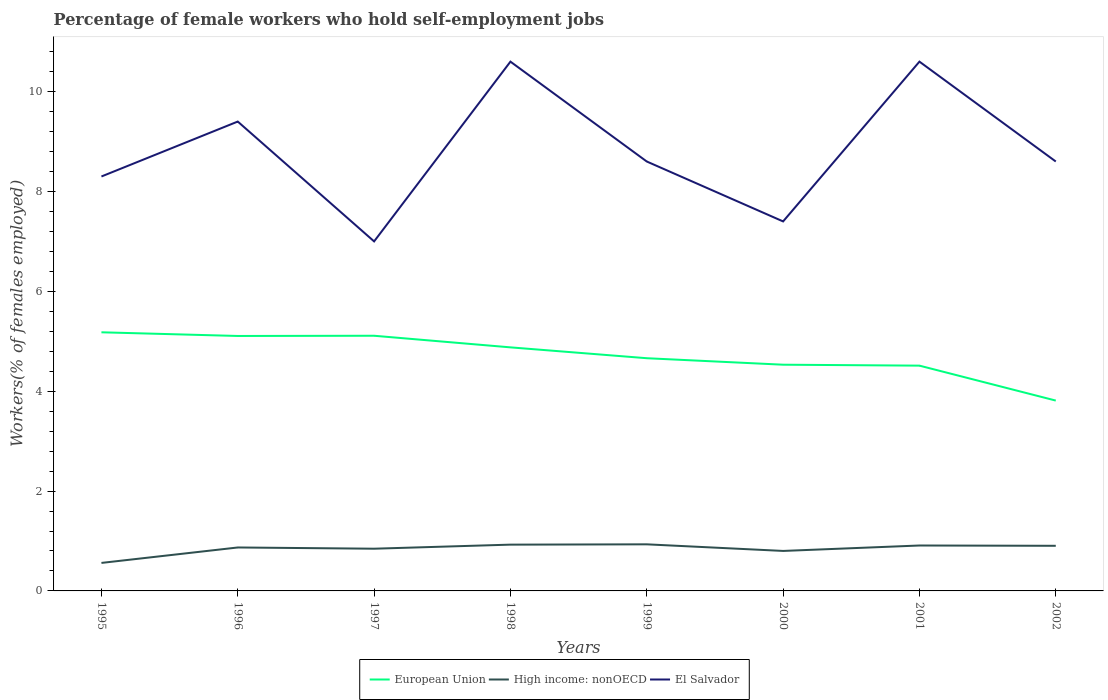How many different coloured lines are there?
Make the answer very short. 3. Does the line corresponding to El Salvador intersect with the line corresponding to European Union?
Your response must be concise. No. Is the number of lines equal to the number of legend labels?
Offer a terse response. Yes. Across all years, what is the maximum percentage of self-employed female workers in High income: nonOECD?
Offer a very short reply. 0.56. What is the total percentage of self-employed female workers in European Union in the graph?
Offer a terse response. 0.58. What is the difference between the highest and the second highest percentage of self-employed female workers in High income: nonOECD?
Give a very brief answer. 0.37. Does the graph contain grids?
Provide a short and direct response. No. Where does the legend appear in the graph?
Provide a succinct answer. Bottom center. How many legend labels are there?
Your response must be concise. 3. What is the title of the graph?
Your response must be concise. Percentage of female workers who hold self-employment jobs. Does "OECD members" appear as one of the legend labels in the graph?
Make the answer very short. No. What is the label or title of the Y-axis?
Keep it short and to the point. Workers(% of females employed). What is the Workers(% of females employed) in European Union in 1995?
Your response must be concise. 5.18. What is the Workers(% of females employed) of High income: nonOECD in 1995?
Your answer should be compact. 0.56. What is the Workers(% of females employed) in El Salvador in 1995?
Offer a terse response. 8.3. What is the Workers(% of females employed) in European Union in 1996?
Provide a short and direct response. 5.11. What is the Workers(% of females employed) of High income: nonOECD in 1996?
Provide a short and direct response. 0.87. What is the Workers(% of females employed) of El Salvador in 1996?
Your answer should be very brief. 9.4. What is the Workers(% of females employed) of European Union in 1997?
Offer a terse response. 5.11. What is the Workers(% of females employed) in High income: nonOECD in 1997?
Provide a short and direct response. 0.85. What is the Workers(% of females employed) in European Union in 1998?
Give a very brief answer. 4.88. What is the Workers(% of females employed) in High income: nonOECD in 1998?
Your response must be concise. 0.93. What is the Workers(% of females employed) of El Salvador in 1998?
Offer a very short reply. 10.6. What is the Workers(% of females employed) in European Union in 1999?
Your response must be concise. 4.66. What is the Workers(% of females employed) in High income: nonOECD in 1999?
Provide a short and direct response. 0.93. What is the Workers(% of females employed) of El Salvador in 1999?
Your response must be concise. 8.6. What is the Workers(% of females employed) in European Union in 2000?
Your answer should be very brief. 4.53. What is the Workers(% of females employed) in High income: nonOECD in 2000?
Keep it short and to the point. 0.8. What is the Workers(% of females employed) in El Salvador in 2000?
Provide a succinct answer. 7.4. What is the Workers(% of females employed) in European Union in 2001?
Provide a short and direct response. 4.51. What is the Workers(% of females employed) of High income: nonOECD in 2001?
Offer a very short reply. 0.91. What is the Workers(% of females employed) of El Salvador in 2001?
Ensure brevity in your answer.  10.6. What is the Workers(% of females employed) in European Union in 2002?
Offer a terse response. 3.81. What is the Workers(% of females employed) in High income: nonOECD in 2002?
Your response must be concise. 0.9. What is the Workers(% of females employed) of El Salvador in 2002?
Provide a succinct answer. 8.6. Across all years, what is the maximum Workers(% of females employed) in European Union?
Provide a short and direct response. 5.18. Across all years, what is the maximum Workers(% of females employed) in High income: nonOECD?
Keep it short and to the point. 0.93. Across all years, what is the maximum Workers(% of females employed) in El Salvador?
Make the answer very short. 10.6. Across all years, what is the minimum Workers(% of females employed) of European Union?
Ensure brevity in your answer.  3.81. Across all years, what is the minimum Workers(% of females employed) of High income: nonOECD?
Offer a very short reply. 0.56. Across all years, what is the minimum Workers(% of females employed) in El Salvador?
Your response must be concise. 7. What is the total Workers(% of females employed) of European Union in the graph?
Make the answer very short. 37.79. What is the total Workers(% of females employed) in High income: nonOECD in the graph?
Your response must be concise. 6.75. What is the total Workers(% of females employed) in El Salvador in the graph?
Make the answer very short. 70.5. What is the difference between the Workers(% of females employed) of European Union in 1995 and that in 1996?
Make the answer very short. 0.07. What is the difference between the Workers(% of females employed) in High income: nonOECD in 1995 and that in 1996?
Your answer should be very brief. -0.31. What is the difference between the Workers(% of females employed) in El Salvador in 1995 and that in 1996?
Offer a very short reply. -1.1. What is the difference between the Workers(% of females employed) of European Union in 1995 and that in 1997?
Give a very brief answer. 0.07. What is the difference between the Workers(% of females employed) of High income: nonOECD in 1995 and that in 1997?
Give a very brief answer. -0.28. What is the difference between the Workers(% of females employed) in El Salvador in 1995 and that in 1997?
Provide a succinct answer. 1.3. What is the difference between the Workers(% of females employed) of European Union in 1995 and that in 1998?
Give a very brief answer. 0.3. What is the difference between the Workers(% of females employed) in High income: nonOECD in 1995 and that in 1998?
Your answer should be very brief. -0.37. What is the difference between the Workers(% of females employed) of European Union in 1995 and that in 1999?
Ensure brevity in your answer.  0.52. What is the difference between the Workers(% of females employed) of High income: nonOECD in 1995 and that in 1999?
Provide a succinct answer. -0.37. What is the difference between the Workers(% of females employed) of El Salvador in 1995 and that in 1999?
Your answer should be compact. -0.3. What is the difference between the Workers(% of females employed) of European Union in 1995 and that in 2000?
Offer a very short reply. 0.65. What is the difference between the Workers(% of females employed) in High income: nonOECD in 1995 and that in 2000?
Offer a very short reply. -0.24. What is the difference between the Workers(% of females employed) in El Salvador in 1995 and that in 2000?
Offer a terse response. 0.9. What is the difference between the Workers(% of females employed) of European Union in 1995 and that in 2001?
Make the answer very short. 0.67. What is the difference between the Workers(% of females employed) in High income: nonOECD in 1995 and that in 2001?
Give a very brief answer. -0.35. What is the difference between the Workers(% of females employed) in El Salvador in 1995 and that in 2001?
Give a very brief answer. -2.3. What is the difference between the Workers(% of females employed) of European Union in 1995 and that in 2002?
Provide a short and direct response. 1.37. What is the difference between the Workers(% of females employed) in High income: nonOECD in 1995 and that in 2002?
Offer a very short reply. -0.34. What is the difference between the Workers(% of females employed) of El Salvador in 1995 and that in 2002?
Provide a succinct answer. -0.3. What is the difference between the Workers(% of females employed) in European Union in 1996 and that in 1997?
Make the answer very short. -0. What is the difference between the Workers(% of females employed) of High income: nonOECD in 1996 and that in 1997?
Offer a very short reply. 0.02. What is the difference between the Workers(% of females employed) in European Union in 1996 and that in 1998?
Make the answer very short. 0.23. What is the difference between the Workers(% of females employed) of High income: nonOECD in 1996 and that in 1998?
Keep it short and to the point. -0.06. What is the difference between the Workers(% of females employed) of El Salvador in 1996 and that in 1998?
Your answer should be very brief. -1.2. What is the difference between the Workers(% of females employed) of European Union in 1996 and that in 1999?
Your answer should be very brief. 0.45. What is the difference between the Workers(% of females employed) of High income: nonOECD in 1996 and that in 1999?
Offer a terse response. -0.06. What is the difference between the Workers(% of females employed) in El Salvador in 1996 and that in 1999?
Provide a short and direct response. 0.8. What is the difference between the Workers(% of females employed) of European Union in 1996 and that in 2000?
Make the answer very short. 0.58. What is the difference between the Workers(% of females employed) in High income: nonOECD in 1996 and that in 2000?
Offer a very short reply. 0.07. What is the difference between the Workers(% of females employed) in El Salvador in 1996 and that in 2000?
Keep it short and to the point. 2. What is the difference between the Workers(% of females employed) in European Union in 1996 and that in 2001?
Provide a succinct answer. 0.59. What is the difference between the Workers(% of females employed) in High income: nonOECD in 1996 and that in 2001?
Provide a short and direct response. -0.04. What is the difference between the Workers(% of females employed) in El Salvador in 1996 and that in 2001?
Make the answer very short. -1.2. What is the difference between the Workers(% of females employed) of European Union in 1996 and that in 2002?
Provide a short and direct response. 1.29. What is the difference between the Workers(% of females employed) in High income: nonOECD in 1996 and that in 2002?
Provide a short and direct response. -0.03. What is the difference between the Workers(% of females employed) in El Salvador in 1996 and that in 2002?
Ensure brevity in your answer.  0.8. What is the difference between the Workers(% of females employed) of European Union in 1997 and that in 1998?
Your answer should be very brief. 0.23. What is the difference between the Workers(% of females employed) in High income: nonOECD in 1997 and that in 1998?
Your answer should be very brief. -0.08. What is the difference between the Workers(% of females employed) of El Salvador in 1997 and that in 1998?
Your response must be concise. -3.6. What is the difference between the Workers(% of females employed) of European Union in 1997 and that in 1999?
Your answer should be very brief. 0.45. What is the difference between the Workers(% of females employed) in High income: nonOECD in 1997 and that in 1999?
Your answer should be very brief. -0.09. What is the difference between the Workers(% of females employed) in European Union in 1997 and that in 2000?
Provide a succinct answer. 0.58. What is the difference between the Workers(% of females employed) in High income: nonOECD in 1997 and that in 2000?
Provide a succinct answer. 0.04. What is the difference between the Workers(% of females employed) in European Union in 1997 and that in 2001?
Ensure brevity in your answer.  0.6. What is the difference between the Workers(% of females employed) of High income: nonOECD in 1997 and that in 2001?
Make the answer very short. -0.06. What is the difference between the Workers(% of females employed) in El Salvador in 1997 and that in 2001?
Provide a succinct answer. -3.6. What is the difference between the Workers(% of females employed) of European Union in 1997 and that in 2002?
Offer a very short reply. 1.3. What is the difference between the Workers(% of females employed) of High income: nonOECD in 1997 and that in 2002?
Your response must be concise. -0.06. What is the difference between the Workers(% of females employed) in European Union in 1998 and that in 1999?
Your response must be concise. 0.22. What is the difference between the Workers(% of females employed) of High income: nonOECD in 1998 and that in 1999?
Offer a very short reply. -0.01. What is the difference between the Workers(% of females employed) of European Union in 1998 and that in 2000?
Offer a terse response. 0.35. What is the difference between the Workers(% of females employed) of High income: nonOECD in 1998 and that in 2000?
Provide a short and direct response. 0.13. What is the difference between the Workers(% of females employed) in El Salvador in 1998 and that in 2000?
Your response must be concise. 3.2. What is the difference between the Workers(% of females employed) in European Union in 1998 and that in 2001?
Keep it short and to the point. 0.37. What is the difference between the Workers(% of females employed) of High income: nonOECD in 1998 and that in 2001?
Your answer should be compact. 0.02. What is the difference between the Workers(% of females employed) in El Salvador in 1998 and that in 2001?
Keep it short and to the point. 0. What is the difference between the Workers(% of females employed) of European Union in 1998 and that in 2002?
Keep it short and to the point. 1.07. What is the difference between the Workers(% of females employed) of High income: nonOECD in 1998 and that in 2002?
Offer a very short reply. 0.02. What is the difference between the Workers(% of females employed) in El Salvador in 1998 and that in 2002?
Ensure brevity in your answer.  2. What is the difference between the Workers(% of females employed) of European Union in 1999 and that in 2000?
Your answer should be compact. 0.13. What is the difference between the Workers(% of females employed) in High income: nonOECD in 1999 and that in 2000?
Offer a terse response. 0.13. What is the difference between the Workers(% of females employed) of European Union in 1999 and that in 2001?
Offer a terse response. 0.15. What is the difference between the Workers(% of females employed) of High income: nonOECD in 1999 and that in 2001?
Give a very brief answer. 0.02. What is the difference between the Workers(% of females employed) in El Salvador in 1999 and that in 2001?
Your answer should be very brief. -2. What is the difference between the Workers(% of females employed) in European Union in 1999 and that in 2002?
Ensure brevity in your answer.  0.85. What is the difference between the Workers(% of females employed) of High income: nonOECD in 1999 and that in 2002?
Offer a terse response. 0.03. What is the difference between the Workers(% of females employed) in European Union in 2000 and that in 2001?
Ensure brevity in your answer.  0.02. What is the difference between the Workers(% of females employed) in High income: nonOECD in 2000 and that in 2001?
Ensure brevity in your answer.  -0.11. What is the difference between the Workers(% of females employed) in El Salvador in 2000 and that in 2001?
Ensure brevity in your answer.  -3.2. What is the difference between the Workers(% of females employed) in European Union in 2000 and that in 2002?
Provide a short and direct response. 0.72. What is the difference between the Workers(% of females employed) of High income: nonOECD in 2000 and that in 2002?
Give a very brief answer. -0.1. What is the difference between the Workers(% of females employed) of El Salvador in 2000 and that in 2002?
Your answer should be very brief. -1.2. What is the difference between the Workers(% of females employed) of European Union in 2001 and that in 2002?
Offer a very short reply. 0.7. What is the difference between the Workers(% of females employed) in High income: nonOECD in 2001 and that in 2002?
Your answer should be compact. 0.01. What is the difference between the Workers(% of females employed) in El Salvador in 2001 and that in 2002?
Make the answer very short. 2. What is the difference between the Workers(% of females employed) of European Union in 1995 and the Workers(% of females employed) of High income: nonOECD in 1996?
Give a very brief answer. 4.31. What is the difference between the Workers(% of females employed) of European Union in 1995 and the Workers(% of females employed) of El Salvador in 1996?
Your answer should be very brief. -4.22. What is the difference between the Workers(% of females employed) in High income: nonOECD in 1995 and the Workers(% of females employed) in El Salvador in 1996?
Make the answer very short. -8.84. What is the difference between the Workers(% of females employed) in European Union in 1995 and the Workers(% of females employed) in High income: nonOECD in 1997?
Offer a very short reply. 4.33. What is the difference between the Workers(% of females employed) in European Union in 1995 and the Workers(% of females employed) in El Salvador in 1997?
Your answer should be compact. -1.82. What is the difference between the Workers(% of females employed) in High income: nonOECD in 1995 and the Workers(% of females employed) in El Salvador in 1997?
Provide a succinct answer. -6.44. What is the difference between the Workers(% of females employed) of European Union in 1995 and the Workers(% of females employed) of High income: nonOECD in 1998?
Give a very brief answer. 4.25. What is the difference between the Workers(% of females employed) of European Union in 1995 and the Workers(% of females employed) of El Salvador in 1998?
Offer a very short reply. -5.42. What is the difference between the Workers(% of females employed) in High income: nonOECD in 1995 and the Workers(% of females employed) in El Salvador in 1998?
Provide a short and direct response. -10.04. What is the difference between the Workers(% of females employed) in European Union in 1995 and the Workers(% of females employed) in High income: nonOECD in 1999?
Offer a terse response. 4.25. What is the difference between the Workers(% of females employed) of European Union in 1995 and the Workers(% of females employed) of El Salvador in 1999?
Give a very brief answer. -3.42. What is the difference between the Workers(% of females employed) in High income: nonOECD in 1995 and the Workers(% of females employed) in El Salvador in 1999?
Provide a short and direct response. -8.04. What is the difference between the Workers(% of females employed) in European Union in 1995 and the Workers(% of females employed) in High income: nonOECD in 2000?
Offer a very short reply. 4.38. What is the difference between the Workers(% of females employed) of European Union in 1995 and the Workers(% of females employed) of El Salvador in 2000?
Make the answer very short. -2.22. What is the difference between the Workers(% of females employed) of High income: nonOECD in 1995 and the Workers(% of females employed) of El Salvador in 2000?
Provide a succinct answer. -6.84. What is the difference between the Workers(% of females employed) of European Union in 1995 and the Workers(% of females employed) of High income: nonOECD in 2001?
Ensure brevity in your answer.  4.27. What is the difference between the Workers(% of females employed) of European Union in 1995 and the Workers(% of females employed) of El Salvador in 2001?
Keep it short and to the point. -5.42. What is the difference between the Workers(% of females employed) of High income: nonOECD in 1995 and the Workers(% of females employed) of El Salvador in 2001?
Ensure brevity in your answer.  -10.04. What is the difference between the Workers(% of females employed) in European Union in 1995 and the Workers(% of females employed) in High income: nonOECD in 2002?
Keep it short and to the point. 4.28. What is the difference between the Workers(% of females employed) of European Union in 1995 and the Workers(% of females employed) of El Salvador in 2002?
Provide a succinct answer. -3.42. What is the difference between the Workers(% of females employed) of High income: nonOECD in 1995 and the Workers(% of females employed) of El Salvador in 2002?
Provide a succinct answer. -8.04. What is the difference between the Workers(% of females employed) of European Union in 1996 and the Workers(% of females employed) of High income: nonOECD in 1997?
Provide a succinct answer. 4.26. What is the difference between the Workers(% of females employed) of European Union in 1996 and the Workers(% of females employed) of El Salvador in 1997?
Your response must be concise. -1.89. What is the difference between the Workers(% of females employed) of High income: nonOECD in 1996 and the Workers(% of females employed) of El Salvador in 1997?
Provide a succinct answer. -6.13. What is the difference between the Workers(% of females employed) of European Union in 1996 and the Workers(% of females employed) of High income: nonOECD in 1998?
Make the answer very short. 4.18. What is the difference between the Workers(% of females employed) of European Union in 1996 and the Workers(% of females employed) of El Salvador in 1998?
Offer a terse response. -5.49. What is the difference between the Workers(% of females employed) of High income: nonOECD in 1996 and the Workers(% of females employed) of El Salvador in 1998?
Give a very brief answer. -9.73. What is the difference between the Workers(% of females employed) in European Union in 1996 and the Workers(% of females employed) in High income: nonOECD in 1999?
Make the answer very short. 4.17. What is the difference between the Workers(% of females employed) in European Union in 1996 and the Workers(% of females employed) in El Salvador in 1999?
Keep it short and to the point. -3.49. What is the difference between the Workers(% of females employed) in High income: nonOECD in 1996 and the Workers(% of females employed) in El Salvador in 1999?
Offer a terse response. -7.73. What is the difference between the Workers(% of females employed) in European Union in 1996 and the Workers(% of females employed) in High income: nonOECD in 2000?
Offer a terse response. 4.3. What is the difference between the Workers(% of females employed) of European Union in 1996 and the Workers(% of females employed) of El Salvador in 2000?
Your response must be concise. -2.29. What is the difference between the Workers(% of females employed) of High income: nonOECD in 1996 and the Workers(% of females employed) of El Salvador in 2000?
Provide a succinct answer. -6.53. What is the difference between the Workers(% of females employed) of European Union in 1996 and the Workers(% of females employed) of High income: nonOECD in 2001?
Offer a very short reply. 4.2. What is the difference between the Workers(% of females employed) in European Union in 1996 and the Workers(% of females employed) in El Salvador in 2001?
Keep it short and to the point. -5.49. What is the difference between the Workers(% of females employed) of High income: nonOECD in 1996 and the Workers(% of females employed) of El Salvador in 2001?
Your response must be concise. -9.73. What is the difference between the Workers(% of females employed) of European Union in 1996 and the Workers(% of females employed) of High income: nonOECD in 2002?
Provide a short and direct response. 4.2. What is the difference between the Workers(% of females employed) of European Union in 1996 and the Workers(% of females employed) of El Salvador in 2002?
Make the answer very short. -3.49. What is the difference between the Workers(% of females employed) in High income: nonOECD in 1996 and the Workers(% of females employed) in El Salvador in 2002?
Offer a very short reply. -7.73. What is the difference between the Workers(% of females employed) of European Union in 1997 and the Workers(% of females employed) of High income: nonOECD in 1998?
Give a very brief answer. 4.18. What is the difference between the Workers(% of females employed) of European Union in 1997 and the Workers(% of females employed) of El Salvador in 1998?
Keep it short and to the point. -5.49. What is the difference between the Workers(% of females employed) in High income: nonOECD in 1997 and the Workers(% of females employed) in El Salvador in 1998?
Offer a terse response. -9.75. What is the difference between the Workers(% of females employed) of European Union in 1997 and the Workers(% of females employed) of High income: nonOECD in 1999?
Your response must be concise. 4.18. What is the difference between the Workers(% of females employed) in European Union in 1997 and the Workers(% of females employed) in El Salvador in 1999?
Provide a short and direct response. -3.49. What is the difference between the Workers(% of females employed) of High income: nonOECD in 1997 and the Workers(% of females employed) of El Salvador in 1999?
Keep it short and to the point. -7.75. What is the difference between the Workers(% of females employed) of European Union in 1997 and the Workers(% of females employed) of High income: nonOECD in 2000?
Provide a short and direct response. 4.31. What is the difference between the Workers(% of females employed) in European Union in 1997 and the Workers(% of females employed) in El Salvador in 2000?
Your answer should be compact. -2.29. What is the difference between the Workers(% of females employed) in High income: nonOECD in 1997 and the Workers(% of females employed) in El Salvador in 2000?
Offer a very short reply. -6.55. What is the difference between the Workers(% of females employed) of European Union in 1997 and the Workers(% of females employed) of High income: nonOECD in 2001?
Provide a short and direct response. 4.2. What is the difference between the Workers(% of females employed) of European Union in 1997 and the Workers(% of females employed) of El Salvador in 2001?
Ensure brevity in your answer.  -5.49. What is the difference between the Workers(% of females employed) in High income: nonOECD in 1997 and the Workers(% of females employed) in El Salvador in 2001?
Provide a succinct answer. -9.75. What is the difference between the Workers(% of females employed) of European Union in 1997 and the Workers(% of females employed) of High income: nonOECD in 2002?
Your answer should be very brief. 4.21. What is the difference between the Workers(% of females employed) in European Union in 1997 and the Workers(% of females employed) in El Salvador in 2002?
Keep it short and to the point. -3.49. What is the difference between the Workers(% of females employed) of High income: nonOECD in 1997 and the Workers(% of females employed) of El Salvador in 2002?
Give a very brief answer. -7.75. What is the difference between the Workers(% of females employed) in European Union in 1998 and the Workers(% of females employed) in High income: nonOECD in 1999?
Your response must be concise. 3.94. What is the difference between the Workers(% of females employed) of European Union in 1998 and the Workers(% of females employed) of El Salvador in 1999?
Make the answer very short. -3.72. What is the difference between the Workers(% of females employed) in High income: nonOECD in 1998 and the Workers(% of females employed) in El Salvador in 1999?
Ensure brevity in your answer.  -7.67. What is the difference between the Workers(% of females employed) in European Union in 1998 and the Workers(% of females employed) in High income: nonOECD in 2000?
Your response must be concise. 4.08. What is the difference between the Workers(% of females employed) in European Union in 1998 and the Workers(% of females employed) in El Salvador in 2000?
Your answer should be very brief. -2.52. What is the difference between the Workers(% of females employed) of High income: nonOECD in 1998 and the Workers(% of females employed) of El Salvador in 2000?
Offer a terse response. -6.47. What is the difference between the Workers(% of females employed) in European Union in 1998 and the Workers(% of females employed) in High income: nonOECD in 2001?
Give a very brief answer. 3.97. What is the difference between the Workers(% of females employed) of European Union in 1998 and the Workers(% of females employed) of El Salvador in 2001?
Keep it short and to the point. -5.72. What is the difference between the Workers(% of females employed) in High income: nonOECD in 1998 and the Workers(% of females employed) in El Salvador in 2001?
Your answer should be very brief. -9.67. What is the difference between the Workers(% of females employed) in European Union in 1998 and the Workers(% of females employed) in High income: nonOECD in 2002?
Your answer should be very brief. 3.97. What is the difference between the Workers(% of females employed) of European Union in 1998 and the Workers(% of females employed) of El Salvador in 2002?
Provide a short and direct response. -3.72. What is the difference between the Workers(% of females employed) of High income: nonOECD in 1998 and the Workers(% of females employed) of El Salvador in 2002?
Offer a terse response. -7.67. What is the difference between the Workers(% of females employed) in European Union in 1999 and the Workers(% of females employed) in High income: nonOECD in 2000?
Provide a short and direct response. 3.86. What is the difference between the Workers(% of females employed) of European Union in 1999 and the Workers(% of females employed) of El Salvador in 2000?
Your answer should be very brief. -2.74. What is the difference between the Workers(% of females employed) in High income: nonOECD in 1999 and the Workers(% of females employed) in El Salvador in 2000?
Ensure brevity in your answer.  -6.47. What is the difference between the Workers(% of females employed) of European Union in 1999 and the Workers(% of females employed) of High income: nonOECD in 2001?
Your response must be concise. 3.75. What is the difference between the Workers(% of females employed) in European Union in 1999 and the Workers(% of females employed) in El Salvador in 2001?
Ensure brevity in your answer.  -5.94. What is the difference between the Workers(% of females employed) of High income: nonOECD in 1999 and the Workers(% of females employed) of El Salvador in 2001?
Ensure brevity in your answer.  -9.67. What is the difference between the Workers(% of females employed) in European Union in 1999 and the Workers(% of females employed) in High income: nonOECD in 2002?
Offer a terse response. 3.76. What is the difference between the Workers(% of females employed) of European Union in 1999 and the Workers(% of females employed) of El Salvador in 2002?
Your answer should be compact. -3.94. What is the difference between the Workers(% of females employed) in High income: nonOECD in 1999 and the Workers(% of females employed) in El Salvador in 2002?
Offer a terse response. -7.67. What is the difference between the Workers(% of females employed) in European Union in 2000 and the Workers(% of females employed) in High income: nonOECD in 2001?
Your answer should be very brief. 3.62. What is the difference between the Workers(% of females employed) in European Union in 2000 and the Workers(% of females employed) in El Salvador in 2001?
Offer a very short reply. -6.07. What is the difference between the Workers(% of females employed) in High income: nonOECD in 2000 and the Workers(% of females employed) in El Salvador in 2001?
Give a very brief answer. -9.8. What is the difference between the Workers(% of females employed) in European Union in 2000 and the Workers(% of females employed) in High income: nonOECD in 2002?
Your answer should be compact. 3.63. What is the difference between the Workers(% of females employed) of European Union in 2000 and the Workers(% of females employed) of El Salvador in 2002?
Offer a terse response. -4.07. What is the difference between the Workers(% of females employed) of High income: nonOECD in 2000 and the Workers(% of females employed) of El Salvador in 2002?
Your answer should be compact. -7.8. What is the difference between the Workers(% of females employed) in European Union in 2001 and the Workers(% of females employed) in High income: nonOECD in 2002?
Offer a terse response. 3.61. What is the difference between the Workers(% of females employed) of European Union in 2001 and the Workers(% of females employed) of El Salvador in 2002?
Provide a short and direct response. -4.09. What is the difference between the Workers(% of females employed) of High income: nonOECD in 2001 and the Workers(% of females employed) of El Salvador in 2002?
Offer a very short reply. -7.69. What is the average Workers(% of females employed) in European Union per year?
Provide a short and direct response. 4.72. What is the average Workers(% of females employed) of High income: nonOECD per year?
Your answer should be very brief. 0.84. What is the average Workers(% of females employed) of El Salvador per year?
Offer a terse response. 8.81. In the year 1995, what is the difference between the Workers(% of females employed) in European Union and Workers(% of females employed) in High income: nonOECD?
Provide a short and direct response. 4.62. In the year 1995, what is the difference between the Workers(% of females employed) in European Union and Workers(% of females employed) in El Salvador?
Give a very brief answer. -3.12. In the year 1995, what is the difference between the Workers(% of females employed) of High income: nonOECD and Workers(% of females employed) of El Salvador?
Provide a succinct answer. -7.74. In the year 1996, what is the difference between the Workers(% of females employed) of European Union and Workers(% of females employed) of High income: nonOECD?
Keep it short and to the point. 4.24. In the year 1996, what is the difference between the Workers(% of females employed) of European Union and Workers(% of females employed) of El Salvador?
Make the answer very short. -4.29. In the year 1996, what is the difference between the Workers(% of females employed) in High income: nonOECD and Workers(% of females employed) in El Salvador?
Keep it short and to the point. -8.53. In the year 1997, what is the difference between the Workers(% of females employed) of European Union and Workers(% of females employed) of High income: nonOECD?
Give a very brief answer. 4.26. In the year 1997, what is the difference between the Workers(% of females employed) in European Union and Workers(% of females employed) in El Salvador?
Your answer should be compact. -1.89. In the year 1997, what is the difference between the Workers(% of females employed) of High income: nonOECD and Workers(% of females employed) of El Salvador?
Your answer should be compact. -6.15. In the year 1998, what is the difference between the Workers(% of females employed) in European Union and Workers(% of females employed) in High income: nonOECD?
Your response must be concise. 3.95. In the year 1998, what is the difference between the Workers(% of females employed) in European Union and Workers(% of females employed) in El Salvador?
Ensure brevity in your answer.  -5.72. In the year 1998, what is the difference between the Workers(% of females employed) in High income: nonOECD and Workers(% of females employed) in El Salvador?
Keep it short and to the point. -9.67. In the year 1999, what is the difference between the Workers(% of females employed) in European Union and Workers(% of females employed) in High income: nonOECD?
Provide a succinct answer. 3.73. In the year 1999, what is the difference between the Workers(% of females employed) in European Union and Workers(% of females employed) in El Salvador?
Give a very brief answer. -3.94. In the year 1999, what is the difference between the Workers(% of females employed) in High income: nonOECD and Workers(% of females employed) in El Salvador?
Offer a terse response. -7.67. In the year 2000, what is the difference between the Workers(% of females employed) of European Union and Workers(% of females employed) of High income: nonOECD?
Provide a short and direct response. 3.73. In the year 2000, what is the difference between the Workers(% of females employed) in European Union and Workers(% of females employed) in El Salvador?
Your answer should be very brief. -2.87. In the year 2000, what is the difference between the Workers(% of females employed) of High income: nonOECD and Workers(% of females employed) of El Salvador?
Ensure brevity in your answer.  -6.6. In the year 2001, what is the difference between the Workers(% of females employed) in European Union and Workers(% of females employed) in High income: nonOECD?
Give a very brief answer. 3.6. In the year 2001, what is the difference between the Workers(% of females employed) of European Union and Workers(% of females employed) of El Salvador?
Offer a very short reply. -6.09. In the year 2001, what is the difference between the Workers(% of females employed) of High income: nonOECD and Workers(% of females employed) of El Salvador?
Your answer should be very brief. -9.69. In the year 2002, what is the difference between the Workers(% of females employed) in European Union and Workers(% of females employed) in High income: nonOECD?
Your answer should be very brief. 2.91. In the year 2002, what is the difference between the Workers(% of females employed) in European Union and Workers(% of females employed) in El Salvador?
Your answer should be very brief. -4.79. In the year 2002, what is the difference between the Workers(% of females employed) in High income: nonOECD and Workers(% of females employed) in El Salvador?
Make the answer very short. -7.7. What is the ratio of the Workers(% of females employed) in European Union in 1995 to that in 1996?
Ensure brevity in your answer.  1.01. What is the ratio of the Workers(% of females employed) of High income: nonOECD in 1995 to that in 1996?
Ensure brevity in your answer.  0.64. What is the ratio of the Workers(% of females employed) of El Salvador in 1995 to that in 1996?
Provide a succinct answer. 0.88. What is the ratio of the Workers(% of females employed) in European Union in 1995 to that in 1997?
Your answer should be compact. 1.01. What is the ratio of the Workers(% of females employed) of High income: nonOECD in 1995 to that in 1997?
Provide a short and direct response. 0.66. What is the ratio of the Workers(% of females employed) in El Salvador in 1995 to that in 1997?
Make the answer very short. 1.19. What is the ratio of the Workers(% of females employed) in European Union in 1995 to that in 1998?
Offer a very short reply. 1.06. What is the ratio of the Workers(% of females employed) of High income: nonOECD in 1995 to that in 1998?
Ensure brevity in your answer.  0.6. What is the ratio of the Workers(% of females employed) in El Salvador in 1995 to that in 1998?
Your answer should be compact. 0.78. What is the ratio of the Workers(% of females employed) in European Union in 1995 to that in 1999?
Provide a succinct answer. 1.11. What is the ratio of the Workers(% of females employed) in High income: nonOECD in 1995 to that in 1999?
Provide a succinct answer. 0.6. What is the ratio of the Workers(% of females employed) in El Salvador in 1995 to that in 1999?
Make the answer very short. 0.97. What is the ratio of the Workers(% of females employed) of European Union in 1995 to that in 2000?
Provide a short and direct response. 1.14. What is the ratio of the Workers(% of females employed) in High income: nonOECD in 1995 to that in 2000?
Keep it short and to the point. 0.7. What is the ratio of the Workers(% of females employed) in El Salvador in 1995 to that in 2000?
Ensure brevity in your answer.  1.12. What is the ratio of the Workers(% of females employed) of European Union in 1995 to that in 2001?
Give a very brief answer. 1.15. What is the ratio of the Workers(% of females employed) of High income: nonOECD in 1995 to that in 2001?
Ensure brevity in your answer.  0.62. What is the ratio of the Workers(% of females employed) of El Salvador in 1995 to that in 2001?
Keep it short and to the point. 0.78. What is the ratio of the Workers(% of females employed) of European Union in 1995 to that in 2002?
Provide a succinct answer. 1.36. What is the ratio of the Workers(% of females employed) in High income: nonOECD in 1995 to that in 2002?
Provide a short and direct response. 0.62. What is the ratio of the Workers(% of females employed) of El Salvador in 1995 to that in 2002?
Keep it short and to the point. 0.97. What is the ratio of the Workers(% of females employed) of High income: nonOECD in 1996 to that in 1997?
Provide a short and direct response. 1.03. What is the ratio of the Workers(% of females employed) of El Salvador in 1996 to that in 1997?
Provide a succinct answer. 1.34. What is the ratio of the Workers(% of females employed) in European Union in 1996 to that in 1998?
Your answer should be very brief. 1.05. What is the ratio of the Workers(% of females employed) of High income: nonOECD in 1996 to that in 1998?
Ensure brevity in your answer.  0.94. What is the ratio of the Workers(% of females employed) of El Salvador in 1996 to that in 1998?
Make the answer very short. 0.89. What is the ratio of the Workers(% of females employed) in European Union in 1996 to that in 1999?
Ensure brevity in your answer.  1.1. What is the ratio of the Workers(% of females employed) of High income: nonOECD in 1996 to that in 1999?
Your answer should be very brief. 0.93. What is the ratio of the Workers(% of females employed) of El Salvador in 1996 to that in 1999?
Offer a terse response. 1.09. What is the ratio of the Workers(% of females employed) in European Union in 1996 to that in 2000?
Your response must be concise. 1.13. What is the ratio of the Workers(% of females employed) of High income: nonOECD in 1996 to that in 2000?
Keep it short and to the point. 1.09. What is the ratio of the Workers(% of females employed) of El Salvador in 1996 to that in 2000?
Your response must be concise. 1.27. What is the ratio of the Workers(% of females employed) in European Union in 1996 to that in 2001?
Offer a terse response. 1.13. What is the ratio of the Workers(% of females employed) of High income: nonOECD in 1996 to that in 2001?
Keep it short and to the point. 0.96. What is the ratio of the Workers(% of females employed) of El Salvador in 1996 to that in 2001?
Make the answer very short. 0.89. What is the ratio of the Workers(% of females employed) of European Union in 1996 to that in 2002?
Offer a very short reply. 1.34. What is the ratio of the Workers(% of females employed) of High income: nonOECD in 1996 to that in 2002?
Give a very brief answer. 0.96. What is the ratio of the Workers(% of females employed) in El Salvador in 1996 to that in 2002?
Your answer should be very brief. 1.09. What is the ratio of the Workers(% of females employed) in European Union in 1997 to that in 1998?
Ensure brevity in your answer.  1.05. What is the ratio of the Workers(% of females employed) of High income: nonOECD in 1997 to that in 1998?
Provide a succinct answer. 0.91. What is the ratio of the Workers(% of females employed) of El Salvador in 1997 to that in 1998?
Offer a terse response. 0.66. What is the ratio of the Workers(% of females employed) of European Union in 1997 to that in 1999?
Provide a short and direct response. 1.1. What is the ratio of the Workers(% of females employed) of High income: nonOECD in 1997 to that in 1999?
Your response must be concise. 0.91. What is the ratio of the Workers(% of females employed) of El Salvador in 1997 to that in 1999?
Offer a very short reply. 0.81. What is the ratio of the Workers(% of females employed) of European Union in 1997 to that in 2000?
Make the answer very short. 1.13. What is the ratio of the Workers(% of females employed) of High income: nonOECD in 1997 to that in 2000?
Your response must be concise. 1.06. What is the ratio of the Workers(% of females employed) of El Salvador in 1997 to that in 2000?
Keep it short and to the point. 0.95. What is the ratio of the Workers(% of females employed) in European Union in 1997 to that in 2001?
Offer a very short reply. 1.13. What is the ratio of the Workers(% of females employed) of High income: nonOECD in 1997 to that in 2001?
Provide a short and direct response. 0.93. What is the ratio of the Workers(% of females employed) in El Salvador in 1997 to that in 2001?
Your response must be concise. 0.66. What is the ratio of the Workers(% of females employed) in European Union in 1997 to that in 2002?
Give a very brief answer. 1.34. What is the ratio of the Workers(% of females employed) in High income: nonOECD in 1997 to that in 2002?
Ensure brevity in your answer.  0.94. What is the ratio of the Workers(% of females employed) of El Salvador in 1997 to that in 2002?
Give a very brief answer. 0.81. What is the ratio of the Workers(% of females employed) in European Union in 1998 to that in 1999?
Your response must be concise. 1.05. What is the ratio of the Workers(% of females employed) of High income: nonOECD in 1998 to that in 1999?
Your answer should be very brief. 0.99. What is the ratio of the Workers(% of females employed) of El Salvador in 1998 to that in 1999?
Your response must be concise. 1.23. What is the ratio of the Workers(% of females employed) in European Union in 1998 to that in 2000?
Your answer should be compact. 1.08. What is the ratio of the Workers(% of females employed) of High income: nonOECD in 1998 to that in 2000?
Your answer should be very brief. 1.16. What is the ratio of the Workers(% of females employed) of El Salvador in 1998 to that in 2000?
Give a very brief answer. 1.43. What is the ratio of the Workers(% of females employed) of European Union in 1998 to that in 2001?
Ensure brevity in your answer.  1.08. What is the ratio of the Workers(% of females employed) of High income: nonOECD in 1998 to that in 2001?
Your answer should be very brief. 1.02. What is the ratio of the Workers(% of females employed) in El Salvador in 1998 to that in 2001?
Offer a very short reply. 1. What is the ratio of the Workers(% of females employed) in European Union in 1998 to that in 2002?
Offer a terse response. 1.28. What is the ratio of the Workers(% of females employed) of High income: nonOECD in 1998 to that in 2002?
Give a very brief answer. 1.03. What is the ratio of the Workers(% of females employed) in El Salvador in 1998 to that in 2002?
Your answer should be compact. 1.23. What is the ratio of the Workers(% of females employed) of European Union in 1999 to that in 2000?
Provide a succinct answer. 1.03. What is the ratio of the Workers(% of females employed) in High income: nonOECD in 1999 to that in 2000?
Provide a succinct answer. 1.17. What is the ratio of the Workers(% of females employed) of El Salvador in 1999 to that in 2000?
Offer a terse response. 1.16. What is the ratio of the Workers(% of females employed) in European Union in 1999 to that in 2001?
Your answer should be compact. 1.03. What is the ratio of the Workers(% of females employed) of High income: nonOECD in 1999 to that in 2001?
Offer a very short reply. 1.03. What is the ratio of the Workers(% of females employed) of El Salvador in 1999 to that in 2001?
Offer a very short reply. 0.81. What is the ratio of the Workers(% of females employed) in European Union in 1999 to that in 2002?
Make the answer very short. 1.22. What is the ratio of the Workers(% of females employed) in High income: nonOECD in 1999 to that in 2002?
Your response must be concise. 1.03. What is the ratio of the Workers(% of females employed) of High income: nonOECD in 2000 to that in 2001?
Your response must be concise. 0.88. What is the ratio of the Workers(% of females employed) in El Salvador in 2000 to that in 2001?
Offer a terse response. 0.7. What is the ratio of the Workers(% of females employed) of European Union in 2000 to that in 2002?
Your answer should be very brief. 1.19. What is the ratio of the Workers(% of females employed) in High income: nonOECD in 2000 to that in 2002?
Make the answer very short. 0.89. What is the ratio of the Workers(% of females employed) of El Salvador in 2000 to that in 2002?
Keep it short and to the point. 0.86. What is the ratio of the Workers(% of females employed) of European Union in 2001 to that in 2002?
Offer a very short reply. 1.18. What is the ratio of the Workers(% of females employed) in High income: nonOECD in 2001 to that in 2002?
Keep it short and to the point. 1.01. What is the ratio of the Workers(% of females employed) in El Salvador in 2001 to that in 2002?
Make the answer very short. 1.23. What is the difference between the highest and the second highest Workers(% of females employed) in European Union?
Give a very brief answer. 0.07. What is the difference between the highest and the second highest Workers(% of females employed) of High income: nonOECD?
Offer a very short reply. 0.01. What is the difference between the highest and the lowest Workers(% of females employed) in European Union?
Ensure brevity in your answer.  1.37. What is the difference between the highest and the lowest Workers(% of females employed) in High income: nonOECD?
Keep it short and to the point. 0.37. What is the difference between the highest and the lowest Workers(% of females employed) in El Salvador?
Make the answer very short. 3.6. 